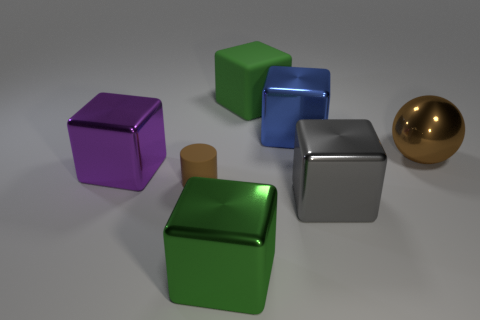Subtract all purple blocks. How many blocks are left? 4 Subtract all large rubber blocks. How many blocks are left? 4 Subtract all red cubes. Subtract all brown cylinders. How many cubes are left? 5 Add 3 big blocks. How many objects exist? 10 Subtract all balls. How many objects are left? 6 Subtract all gray things. Subtract all small matte cylinders. How many objects are left? 5 Add 5 purple cubes. How many purple cubes are left? 6 Add 3 big matte objects. How many big matte objects exist? 4 Subtract 0 yellow cylinders. How many objects are left? 7 